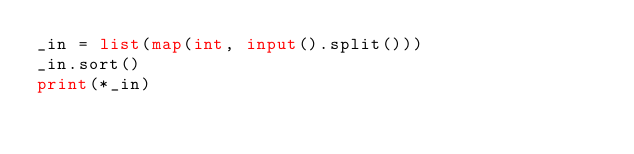<code> <loc_0><loc_0><loc_500><loc_500><_Python_>_in = list(map(int, input().split()))
_in.sort()
print(*_in)
</code> 